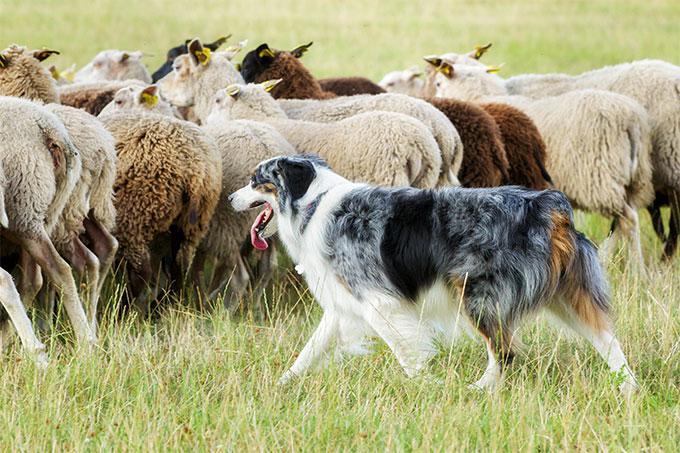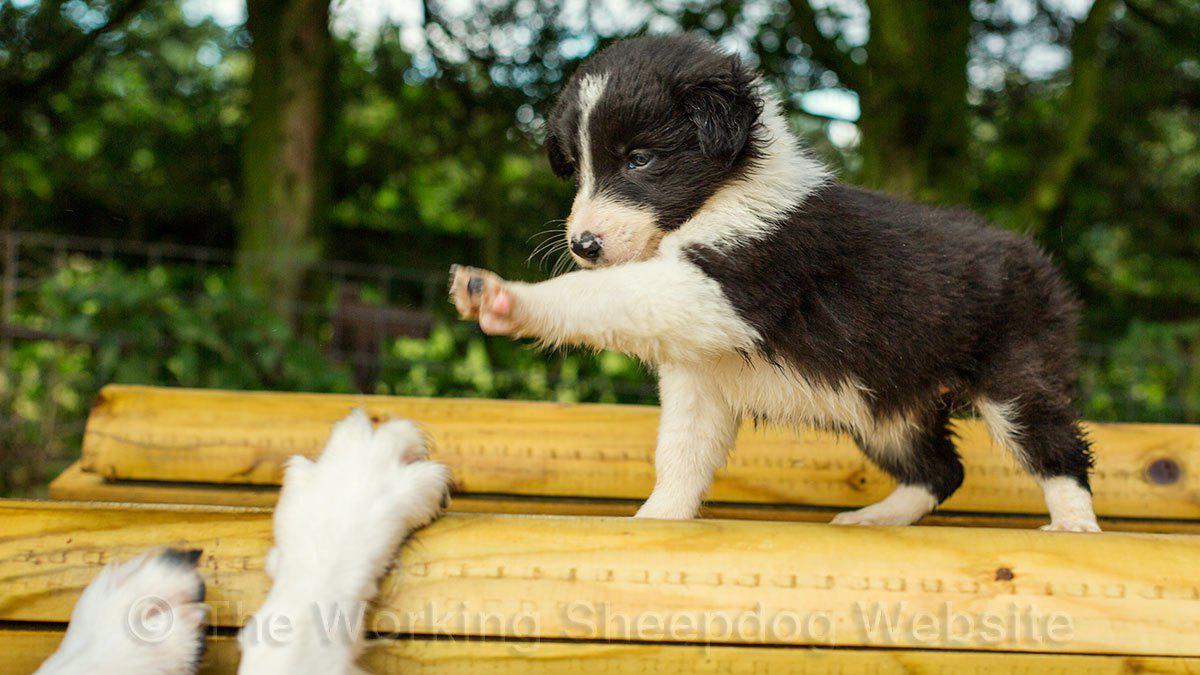The first image is the image on the left, the second image is the image on the right. Given the left and right images, does the statement "There are two dogs in the image on the right" hold true? Answer yes or no. Yes. The first image is the image on the left, the second image is the image on the right. Evaluate the accuracy of this statement regarding the images: "A dog has at least one paw in the air.". Is it true? Answer yes or no. Yes. 